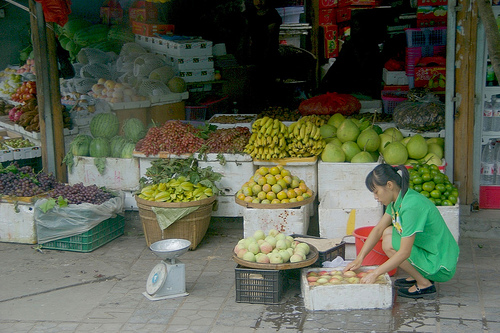<image>
Is there a fruits behind the pole? No. The fruits is not behind the pole. From this viewpoint, the fruits appears to be positioned elsewhere in the scene. 